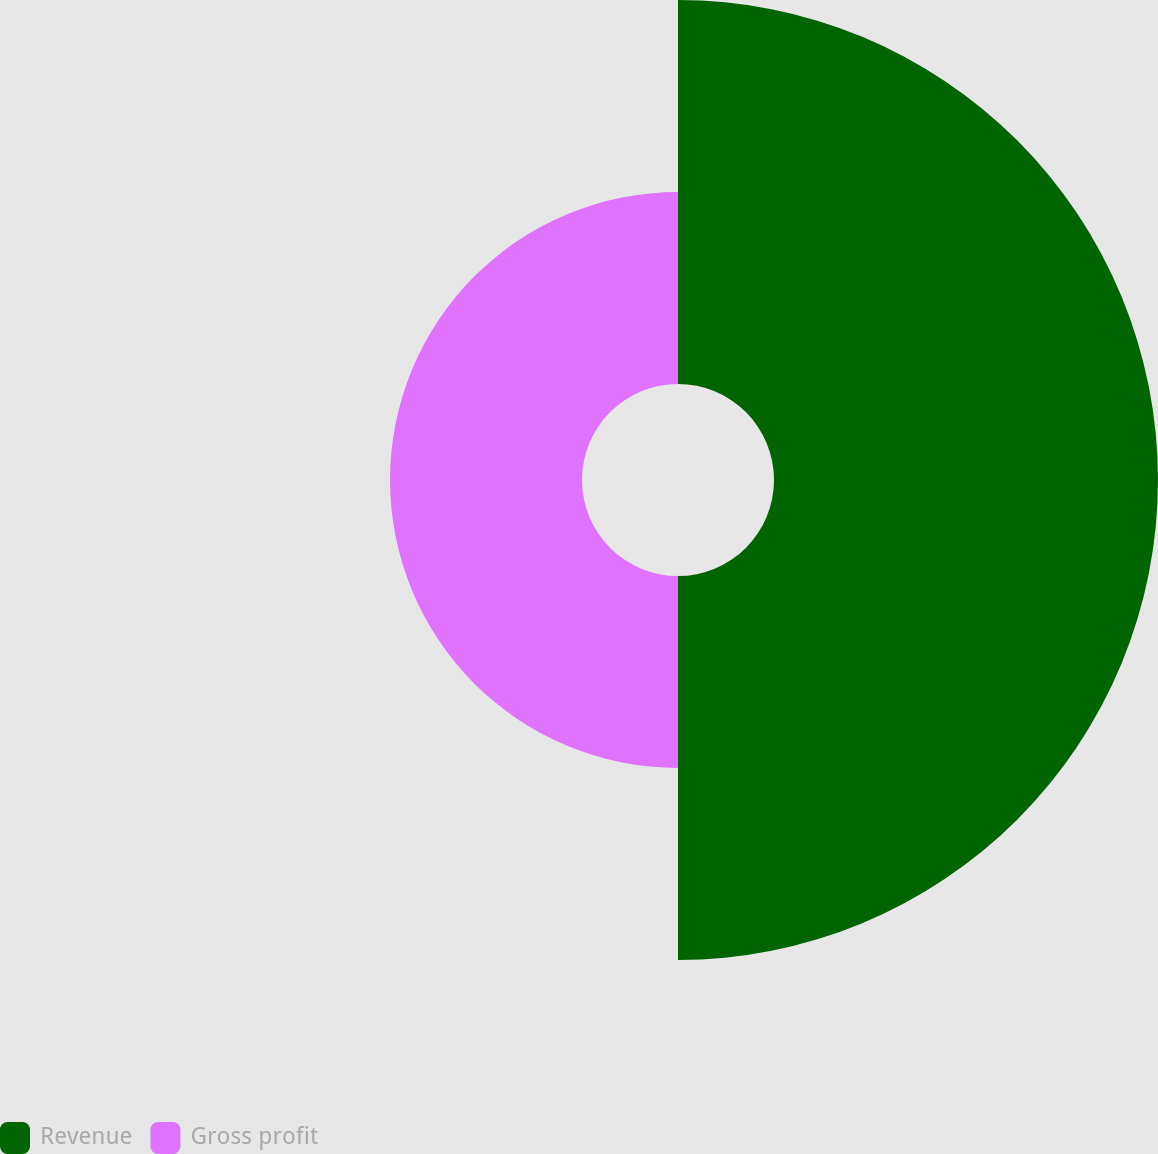Convert chart. <chart><loc_0><loc_0><loc_500><loc_500><pie_chart><fcel>Revenue<fcel>Gross profit<nl><fcel>66.67%<fcel>33.33%<nl></chart> 